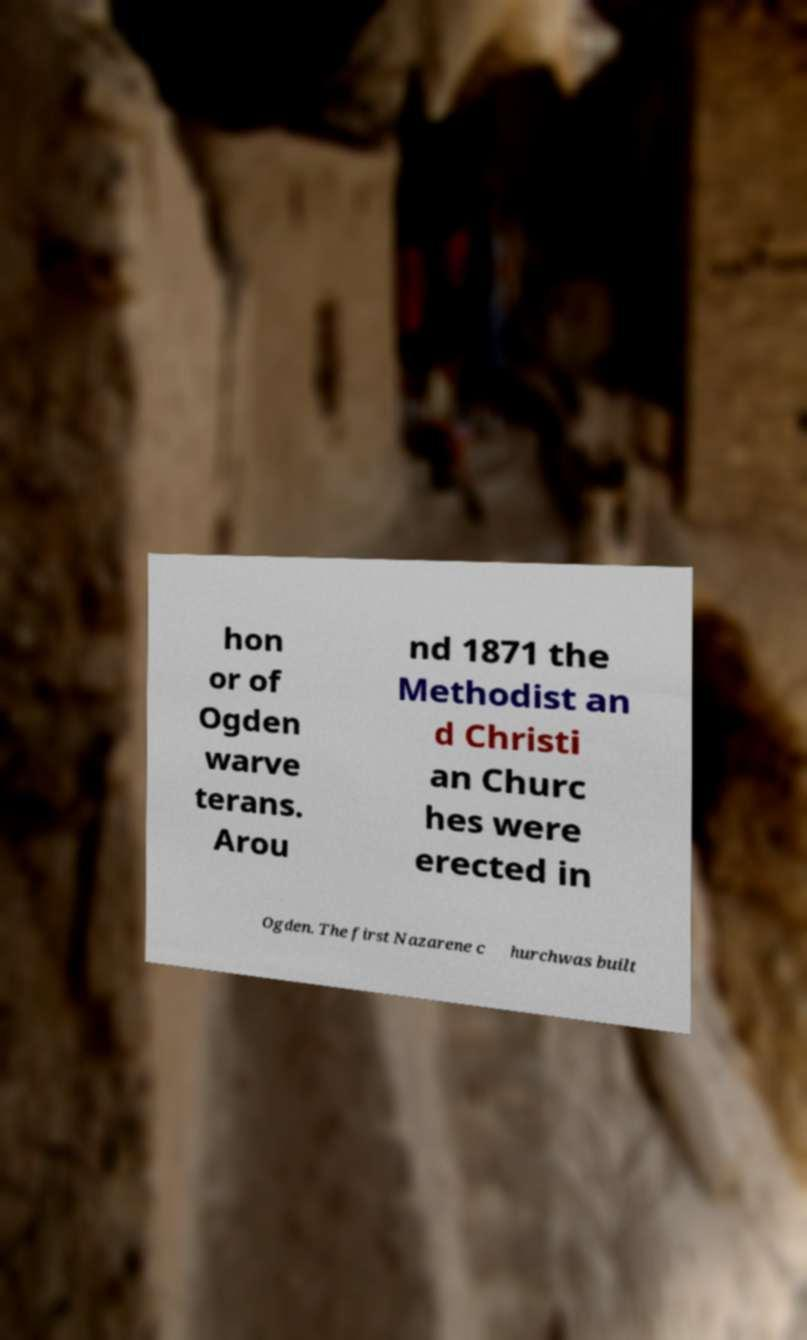Can you accurately transcribe the text from the provided image for me? hon or of Ogden warve terans. Arou nd 1871 the Methodist an d Christi an Churc hes were erected in Ogden. The first Nazarene c hurchwas built 